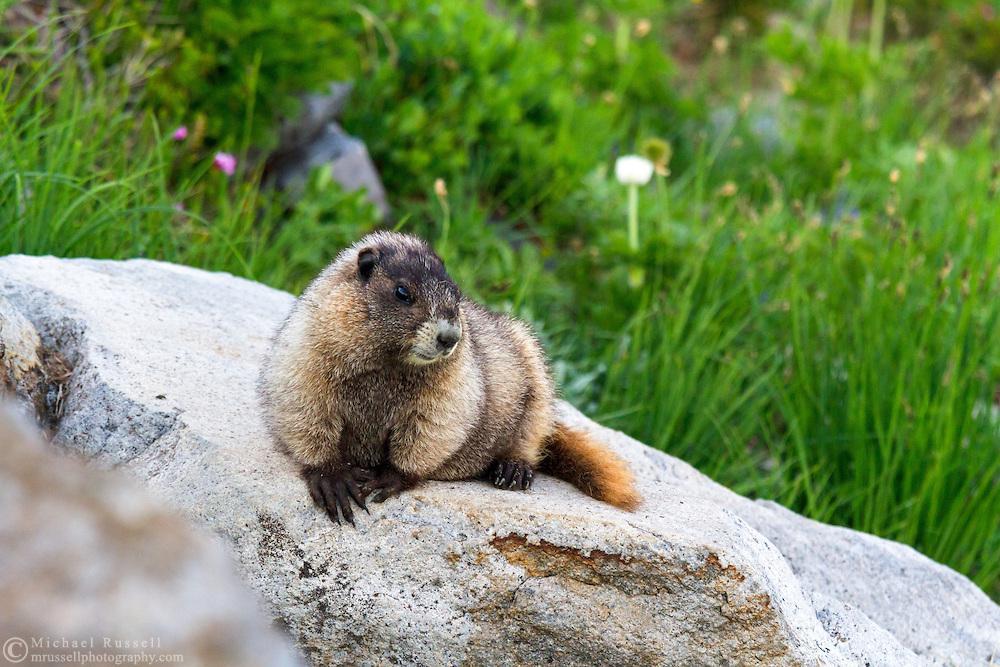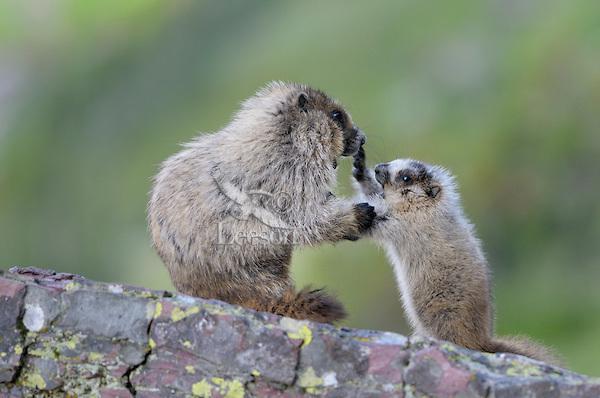The first image is the image on the left, the second image is the image on the right. Evaluate the accuracy of this statement regarding the images: "There is 1 or more woodchucks facing right.". Is it true? Answer yes or no. Yes. The first image is the image on the left, the second image is the image on the right. Evaluate the accuracy of this statement regarding the images: "In one of the photos, the marmot's nose is near a blossom.". Is it true? Answer yes or no. No. 